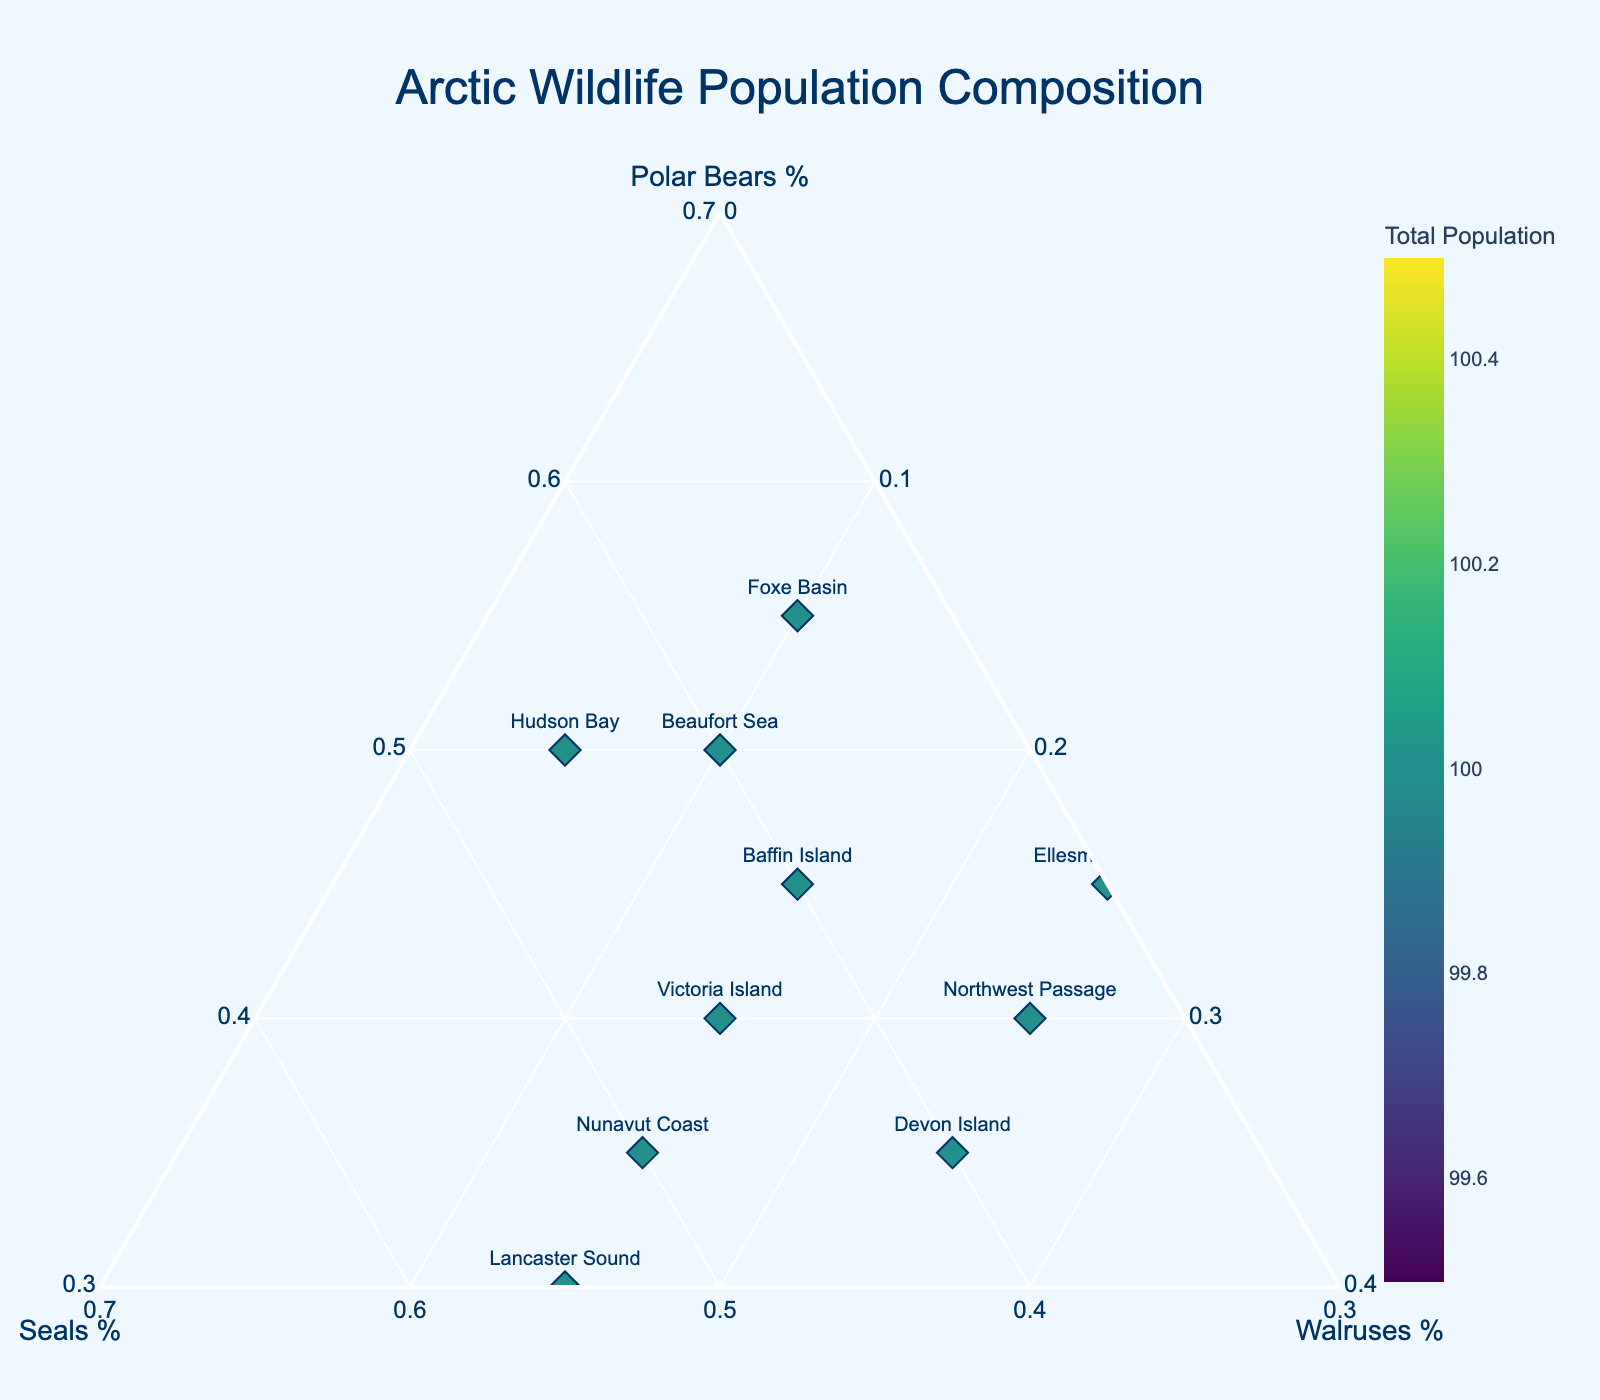What is the title of the ternary plot? The title of the ternary plot is located at the top and is usually the largest text on the plot, making it easy to identify.
Answer: Arctic Wildlife Population Composition How many different locations are represented in the plot? There are 10 unique data points represented, each labeled with a different location name.
Answer: 10 Which location has the highest percentage of seals? Locate each point labeled with their respective locations and compare the 'Seals %' value by observing their position on the ternary plot. The point that is closest to the 'Seals %' axis with the highest percentage is "Lancaster Sound".
Answer: Lancaster Sound Which location has the smallest total wildlife population? Refer to the color scale that represents the total population, the lightest colored data point indicates the smallest population. "Hudson Bay" has the smallest total wildlife population.
Answer: Hudson Bay Is there a location where the percentage of polar bears and seals is equal? Examine each labeled point and check if the 'Polar Bears %' is equal to 'Seals %'. No data point has equal percentages for polar bears and seals.
Answer: No Which location shows the largest percentage of walruses? Check the position of each point in relation to the 'Walruses %' axis, which starts from the base of the triangle. The location closest to this axis, with the highest percentage, is "Northwest Passage".
Answer: Northwest Passage How does the composition of polar bears at Baffin Island compare to Ellesmere Island? Identify both locations on the plot and compare their 'Polar Bears %'. Baffin Island has 45%, while Ellesmere Island also has 45%. Hence, both have the same percentage of polar bears.
Answer: Same Calculate the average percentage of seals across all locations. Add the 'Seals %' for all locations (40 + 45 + 50 + 35 + 55 + 35 + 45 + 40 + 30 + 40 = 415) and divide by the number of locations (10). So, the average percentage is 415/10 = 41.5%.
Answer: 41.5% Which location has an approximately equal percentage of all three animals? A point with equal composition will be closest to the center of the ternary plot. "Victoria Island" has percentages close to 33% for each category.
Answer: Victoria Island What is the relationship between the total population and the color intensity used in the markers? Higher total populations are represented with darker colors, while lower populations are represented with lighter colors as indicated by the colorbar.
Answer: Darker colors = Higher total population 